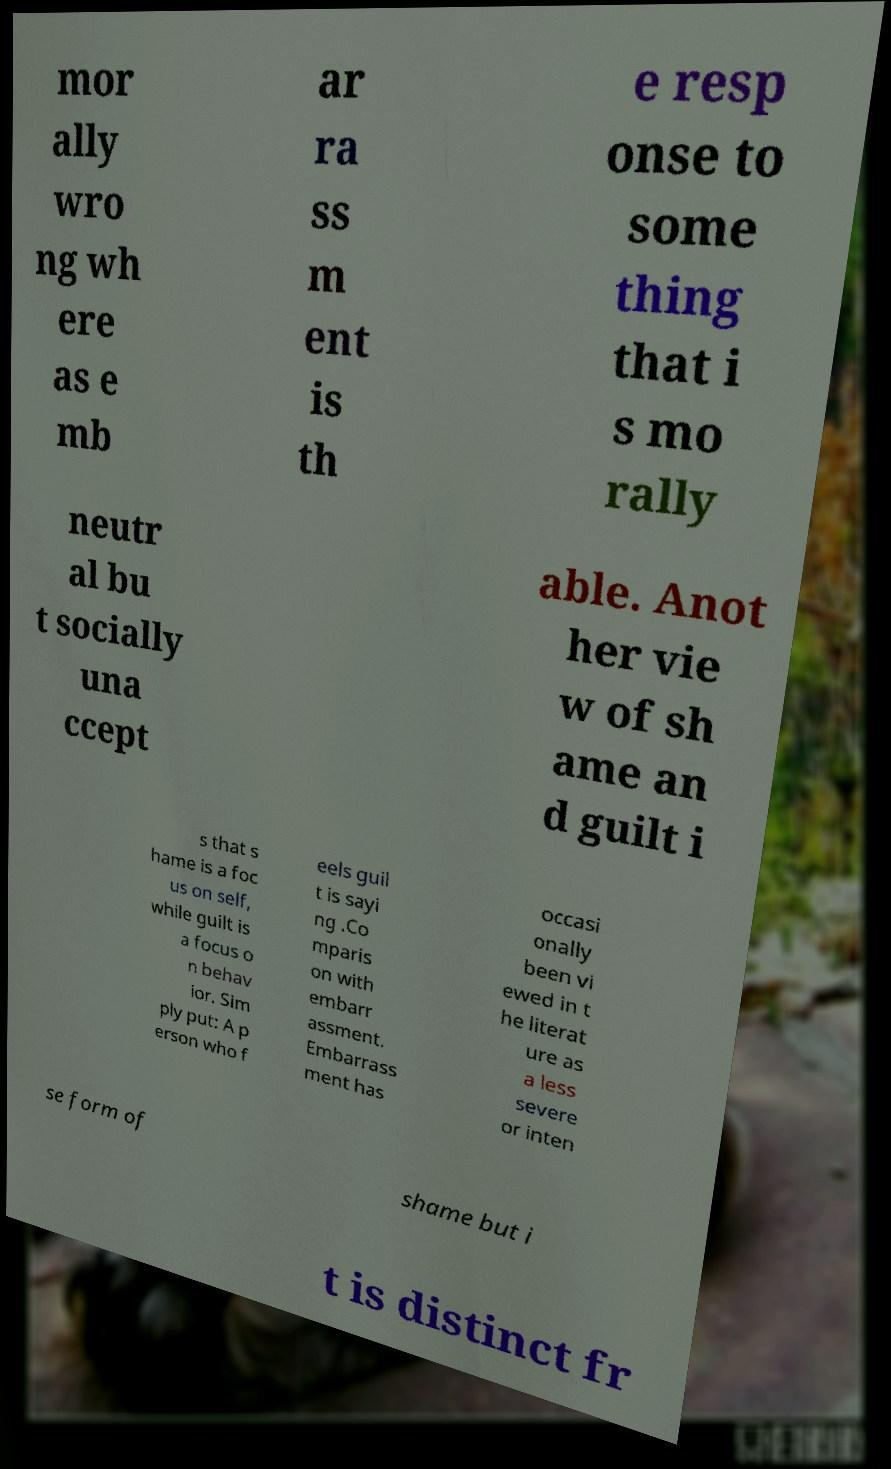I need the written content from this picture converted into text. Can you do that? mor ally wro ng wh ere as e mb ar ra ss m ent is th e resp onse to some thing that i s mo rally neutr al bu t socially una ccept able. Anot her vie w of sh ame an d guilt i s that s hame is a foc us on self, while guilt is a focus o n behav ior. Sim ply put: A p erson who f eels guil t is sayi ng .Co mparis on with embarr assment. Embarrass ment has occasi onally been vi ewed in t he literat ure as a less severe or inten se form of shame but i t is distinct fr 